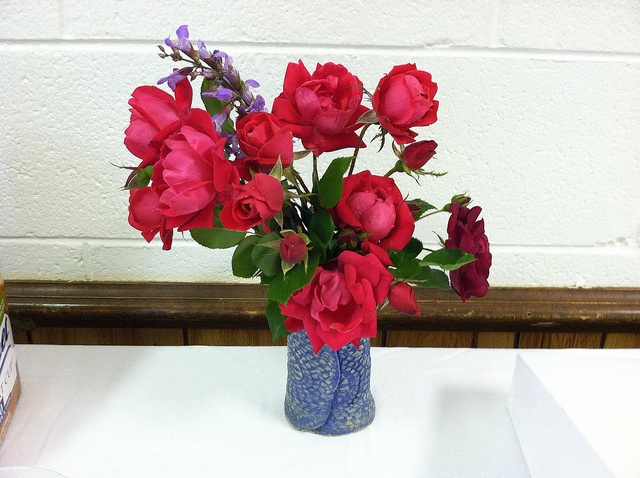Describe the objects in this image and their specific colors. I can see dining table in lightgray, white, and darkgray tones and vase in lightgray, gray, and darkgray tones in this image. 